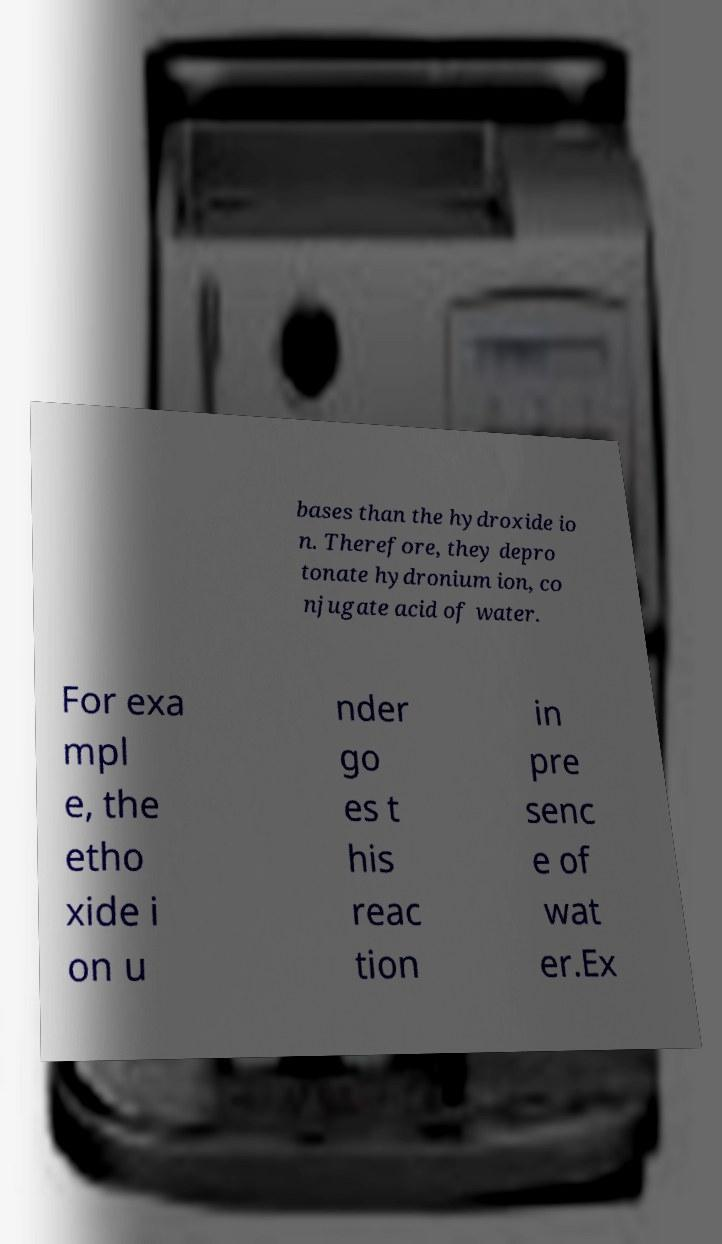For documentation purposes, I need the text within this image transcribed. Could you provide that? bases than the hydroxide io n. Therefore, they depro tonate hydronium ion, co njugate acid of water. For exa mpl e, the etho xide i on u nder go es t his reac tion in pre senc e of wat er.Ex 